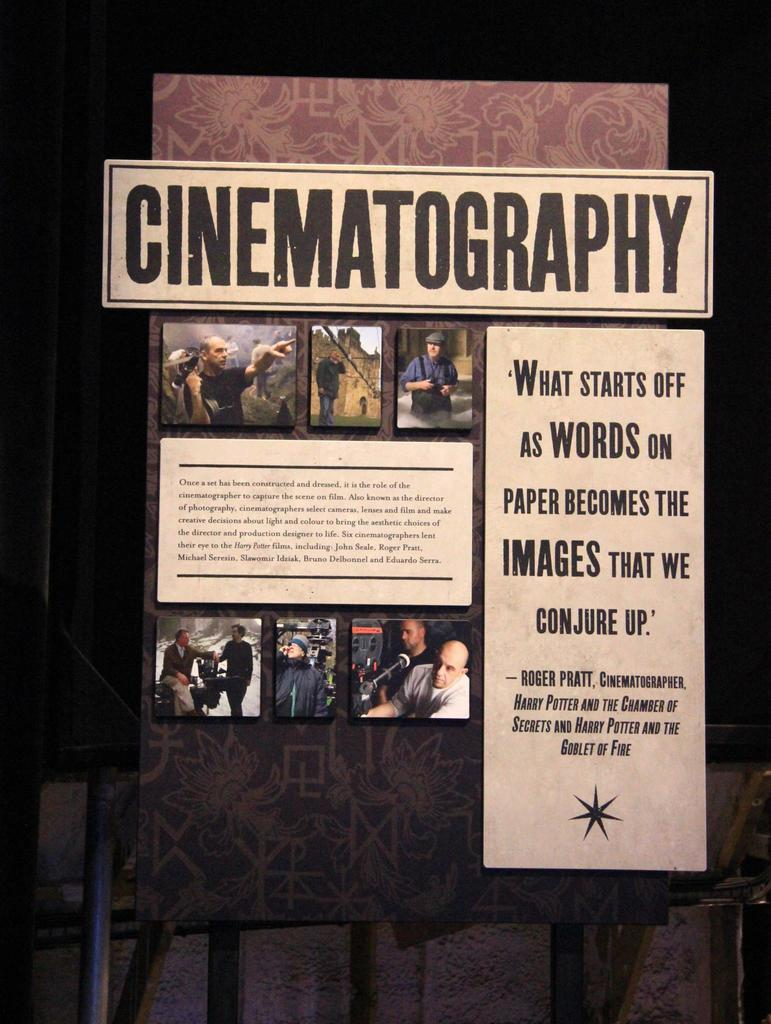Provide a one-sentence caption for the provided image. A sign about Cinematography with a quote from Roger Pratt. 